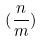<formula> <loc_0><loc_0><loc_500><loc_500>( \frac { n } { m } )</formula> 